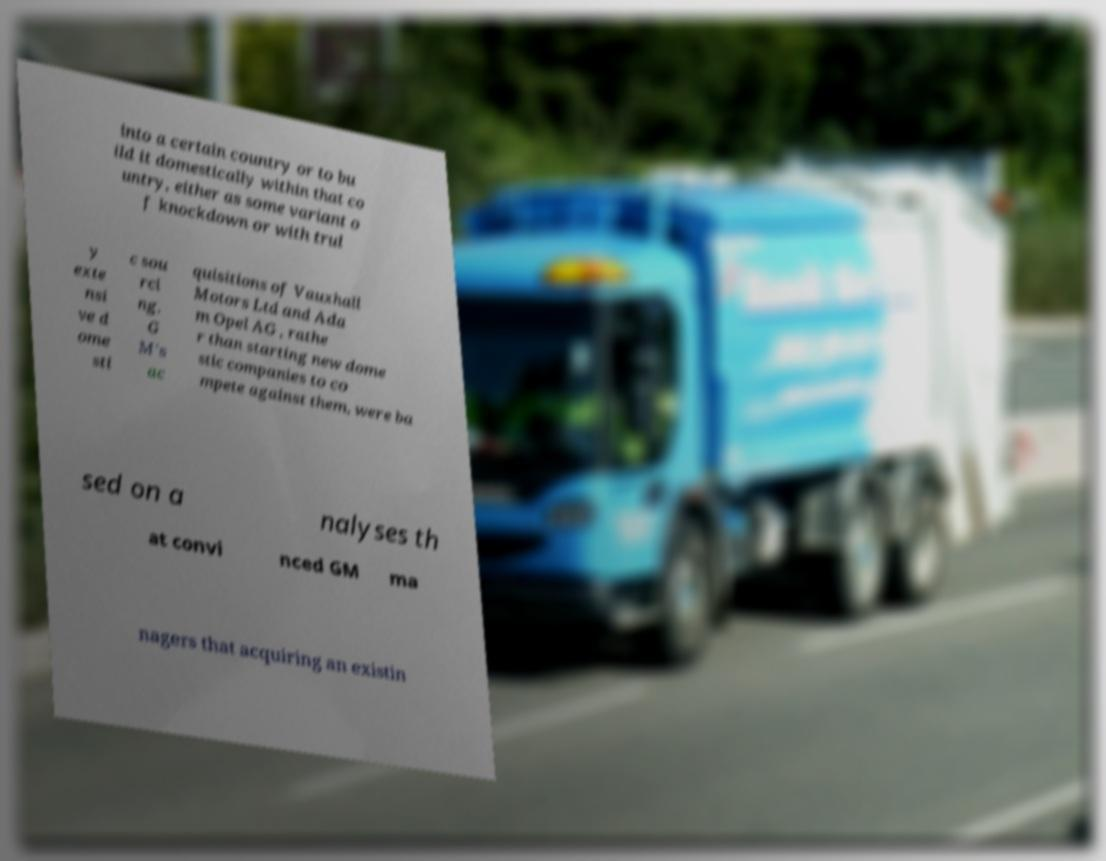Please identify and transcribe the text found in this image. into a certain country or to bu ild it domestically within that co untry, either as some variant o f knockdown or with trul y exte nsi ve d ome sti c sou rci ng. G M's ac quisitions of Vauxhall Motors Ltd and Ada m Opel AG , rathe r than starting new dome stic companies to co mpete against them, were ba sed on a nalyses th at convi nced GM ma nagers that acquiring an existin 